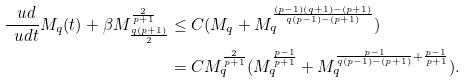Convert formula to latex. <formula><loc_0><loc_0><loc_500><loc_500>\frac { \ u d } { \ u d t } M _ { q } ( t ) + \beta M _ { \frac { q ( p + 1 ) } { 2 } } ^ { \frac { 2 } { p + 1 } } & \leq C ( M _ { q } + M _ { q } ^ { \frac { ( p - 1 ) ( q + 1 ) - ( p + 1 ) } { q ( p - 1 ) - ( p + 1 ) } } ) \\ & = C M _ { q } ^ { \frac { 2 } { p + 1 } } ( M _ { q } ^ { \frac { p - 1 } { p + 1 } } + M _ { q } ^ { \frac { p - 1 } { q ( p - 1 ) - ( p + 1 ) } + \frac { p - 1 } { p + 1 } } ) .</formula> 